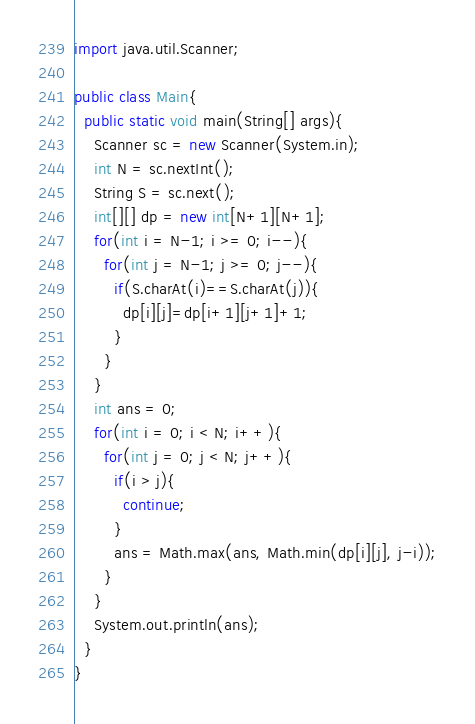<code> <loc_0><loc_0><loc_500><loc_500><_Java_>import java.util.Scanner;

public class Main{
  public static void main(String[] args){
    Scanner sc = new Scanner(System.in);
    int N = sc.nextInt();
    String S = sc.next();
    int[][] dp = new int[N+1][N+1];
    for(int i = N-1; i >= 0; i--){
      for(int j = N-1; j >= 0; j--){
        if(S.charAt(i)==S.charAt(j)){
          dp[i][j]=dp[i+1][j+1]+1;
        }
      }
    }
    int ans = 0;
    for(int i = 0; i < N; i++){
      for(int j = 0; j < N; j++){
        if(i > j){
          continue;
        }
        ans = Math.max(ans, Math.min(dp[i][j], j-i));
      }
    }
    System.out.println(ans);
  }
}</code> 